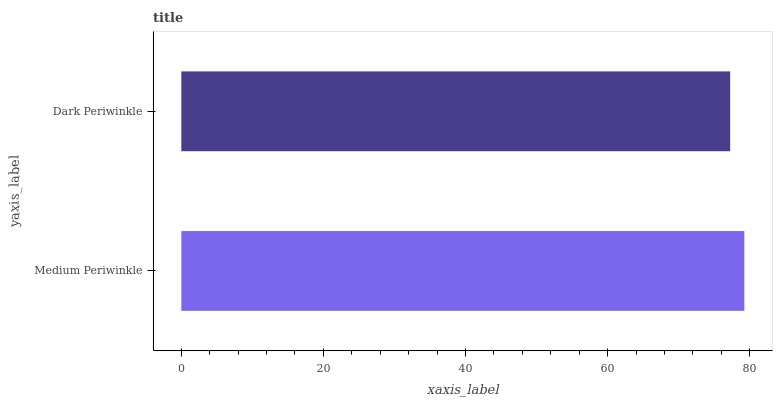Is Dark Periwinkle the minimum?
Answer yes or no. Yes. Is Medium Periwinkle the maximum?
Answer yes or no. Yes. Is Dark Periwinkle the maximum?
Answer yes or no. No. Is Medium Periwinkle greater than Dark Periwinkle?
Answer yes or no. Yes. Is Dark Periwinkle less than Medium Periwinkle?
Answer yes or no. Yes. Is Dark Periwinkle greater than Medium Periwinkle?
Answer yes or no. No. Is Medium Periwinkle less than Dark Periwinkle?
Answer yes or no. No. Is Medium Periwinkle the high median?
Answer yes or no. Yes. Is Dark Periwinkle the low median?
Answer yes or no. Yes. Is Dark Periwinkle the high median?
Answer yes or no. No. Is Medium Periwinkle the low median?
Answer yes or no. No. 